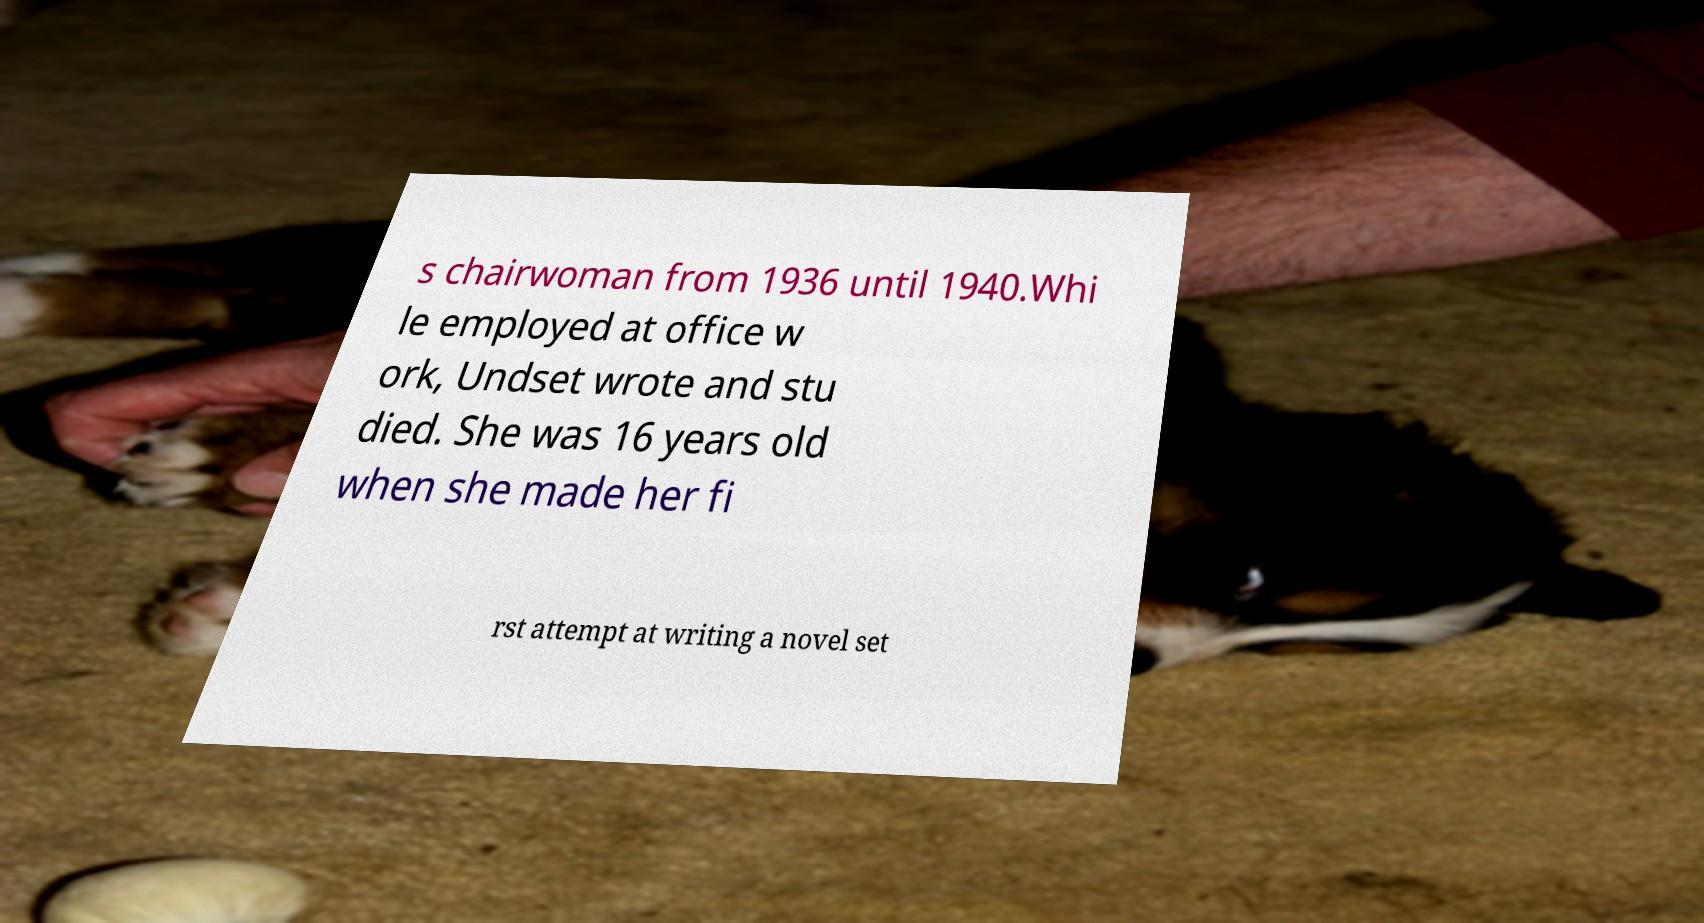Could you extract and type out the text from this image? s chairwoman from 1936 until 1940.Whi le employed at office w ork, Undset wrote and stu died. She was 16 years old when she made her fi rst attempt at writing a novel set 